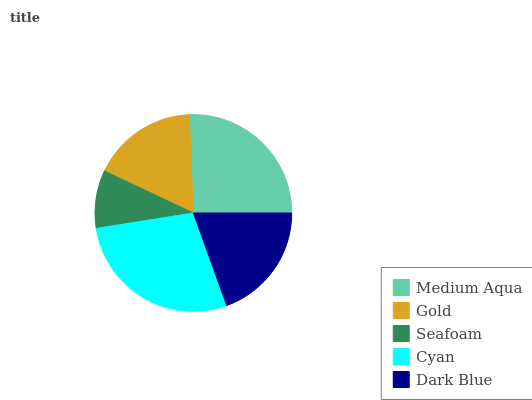Is Seafoam the minimum?
Answer yes or no. Yes. Is Cyan the maximum?
Answer yes or no. Yes. Is Gold the minimum?
Answer yes or no. No. Is Gold the maximum?
Answer yes or no. No. Is Medium Aqua greater than Gold?
Answer yes or no. Yes. Is Gold less than Medium Aqua?
Answer yes or no. Yes. Is Gold greater than Medium Aqua?
Answer yes or no. No. Is Medium Aqua less than Gold?
Answer yes or no. No. Is Dark Blue the high median?
Answer yes or no. Yes. Is Dark Blue the low median?
Answer yes or no. Yes. Is Seafoam the high median?
Answer yes or no. No. Is Seafoam the low median?
Answer yes or no. No. 